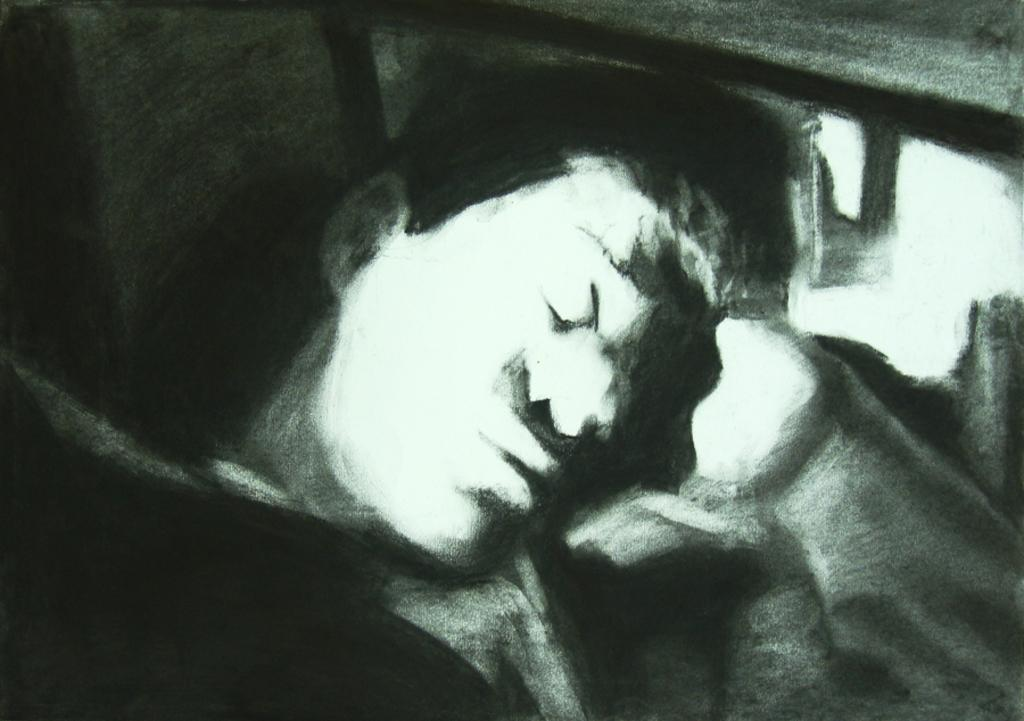What is the main subject of the image? There is a portrait of a man in the image. Can you describe the man in the portrait? Unfortunately, the provided facts do not include any details about the man's appearance or clothing. What is the setting or background of the portrait? The provided facts do not include any information about the setting or background of the portrait. Where is the bat hanging from the net in the image? There is no bat or net present in the image; it only features a portrait of a man. 